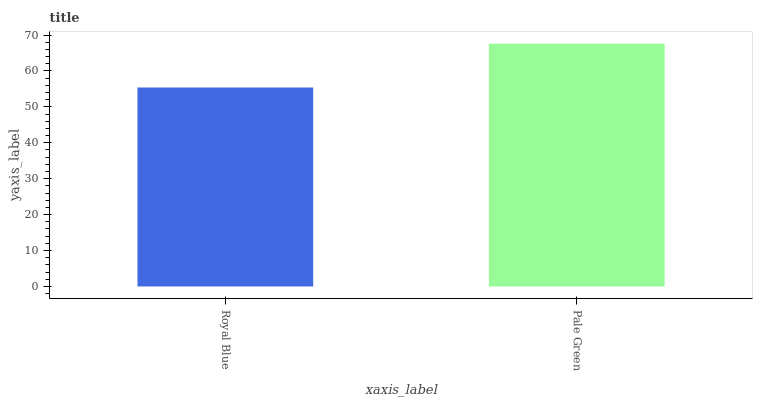Is Royal Blue the minimum?
Answer yes or no. Yes. Is Pale Green the maximum?
Answer yes or no. Yes. Is Pale Green the minimum?
Answer yes or no. No. Is Pale Green greater than Royal Blue?
Answer yes or no. Yes. Is Royal Blue less than Pale Green?
Answer yes or no. Yes. Is Royal Blue greater than Pale Green?
Answer yes or no. No. Is Pale Green less than Royal Blue?
Answer yes or no. No. Is Pale Green the high median?
Answer yes or no. Yes. Is Royal Blue the low median?
Answer yes or no. Yes. Is Royal Blue the high median?
Answer yes or no. No. Is Pale Green the low median?
Answer yes or no. No. 